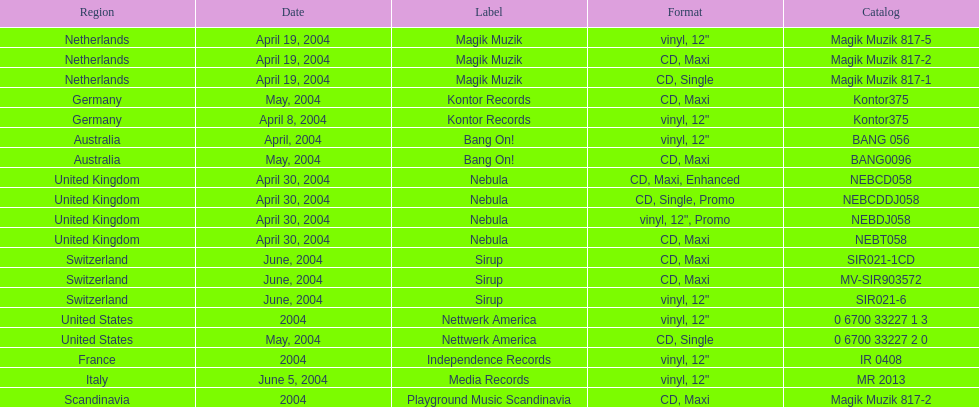What region is listed at the top? Netherlands. 